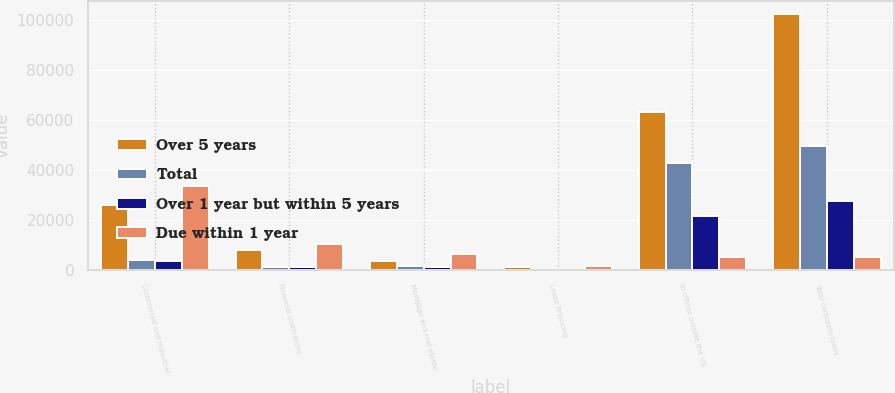<chart> <loc_0><loc_0><loc_500><loc_500><stacked_bar_chart><ecel><fcel>Commercial and industrial<fcel>Financial institutions<fcel>Mortgage and real estate<fcel>Lease financing<fcel>In offices outside the US<fcel>Total corporate loans<nl><fcel>Over 5 years<fcel>25913<fcel>8110<fcel>3690<fcel>1173<fcel>63249<fcel>102135<nl><fcel>Total<fcel>3827<fcel>1061<fcel>1609<fcel>154<fcel>42760<fcel>49411<nl><fcel>Over 1 year but within 5 years<fcel>3710<fcel>1029<fcel>1261<fcel>149<fcel>21508<fcel>27657<nl><fcel>Due within 1 year<fcel>33450<fcel>10200<fcel>6560<fcel>1476<fcel>5193.5<fcel>5193.5<nl></chart> 